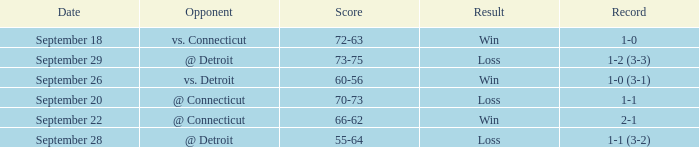Could you parse the entire table as a dict? {'header': ['Date', 'Opponent', 'Score', 'Result', 'Record'], 'rows': [['September 18', 'vs. Connecticut', '72-63', 'Win', '1-0'], ['September 29', '@ Detroit', '73-75', 'Loss', '1-2 (3-3)'], ['September 26', 'vs. Detroit', '60-56', 'Win', '1-0 (3-1)'], ['September 20', '@ Connecticut', '70-73', 'Loss', '1-1'], ['September 22', '@ Connecticut', '66-62', 'Win', '2-1'], ['September 28', '@ Detroit', '55-64', 'Loss', '1-1 (3-2)']]} What is the date with score of 66-62? September 22. 